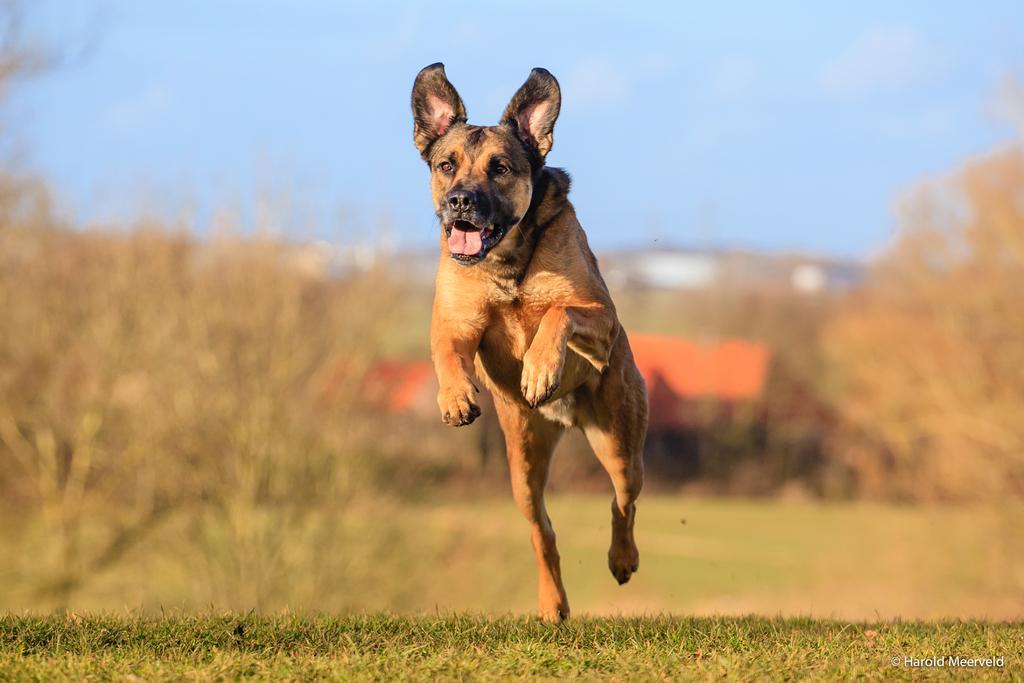Could you give a brief overview of what you see in this image? In this picture there is a dog who is running on the ground. In the background I can see the buildings, mountains and trees. At the top I can see the sky and clouds. At the bottom I can see the grass. In the bottom right corner there is a watermark. 